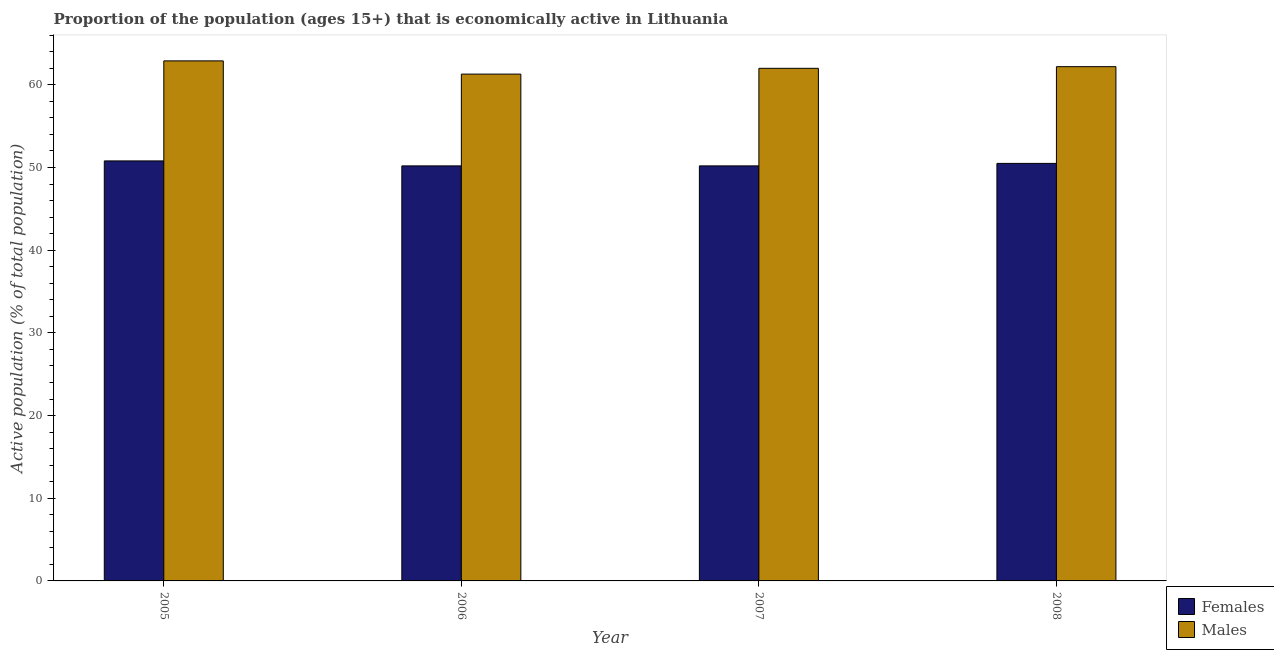How many groups of bars are there?
Your answer should be compact. 4. Are the number of bars on each tick of the X-axis equal?
Your answer should be very brief. Yes. How many bars are there on the 3rd tick from the right?
Keep it short and to the point. 2. What is the percentage of economically active female population in 2007?
Ensure brevity in your answer.  50.2. Across all years, what is the maximum percentage of economically active female population?
Your answer should be very brief. 50.8. Across all years, what is the minimum percentage of economically active male population?
Your response must be concise. 61.3. What is the total percentage of economically active male population in the graph?
Ensure brevity in your answer.  248.4. What is the difference between the percentage of economically active female population in 2005 and the percentage of economically active male population in 2006?
Provide a short and direct response. 0.6. What is the average percentage of economically active male population per year?
Offer a very short reply. 62.1. In the year 2007, what is the difference between the percentage of economically active female population and percentage of economically active male population?
Your answer should be very brief. 0. What is the ratio of the percentage of economically active female population in 2007 to that in 2008?
Offer a very short reply. 0.99. Is the percentage of economically active male population in 2006 less than that in 2007?
Your answer should be very brief. Yes. Is the difference between the percentage of economically active male population in 2007 and 2008 greater than the difference between the percentage of economically active female population in 2007 and 2008?
Keep it short and to the point. No. What is the difference between the highest and the second highest percentage of economically active female population?
Your response must be concise. 0.3. What is the difference between the highest and the lowest percentage of economically active female population?
Ensure brevity in your answer.  0.6. In how many years, is the percentage of economically active male population greater than the average percentage of economically active male population taken over all years?
Your answer should be compact. 2. Is the sum of the percentage of economically active female population in 2005 and 2007 greater than the maximum percentage of economically active male population across all years?
Provide a short and direct response. Yes. What does the 2nd bar from the left in 2006 represents?
Ensure brevity in your answer.  Males. What does the 1st bar from the right in 2005 represents?
Your response must be concise. Males. How many bars are there?
Make the answer very short. 8. Are all the bars in the graph horizontal?
Make the answer very short. No. Does the graph contain grids?
Keep it short and to the point. No. Where does the legend appear in the graph?
Ensure brevity in your answer.  Bottom right. How are the legend labels stacked?
Offer a very short reply. Vertical. What is the title of the graph?
Offer a very short reply. Proportion of the population (ages 15+) that is economically active in Lithuania. What is the label or title of the X-axis?
Provide a succinct answer. Year. What is the label or title of the Y-axis?
Your answer should be compact. Active population (% of total population). What is the Active population (% of total population) of Females in 2005?
Provide a succinct answer. 50.8. What is the Active population (% of total population) of Males in 2005?
Offer a very short reply. 62.9. What is the Active population (% of total population) of Females in 2006?
Offer a very short reply. 50.2. What is the Active population (% of total population) of Males in 2006?
Your response must be concise. 61.3. What is the Active population (% of total population) in Females in 2007?
Your response must be concise. 50.2. What is the Active population (% of total population) of Females in 2008?
Provide a succinct answer. 50.5. What is the Active population (% of total population) of Males in 2008?
Provide a short and direct response. 62.2. Across all years, what is the maximum Active population (% of total population) of Females?
Give a very brief answer. 50.8. Across all years, what is the maximum Active population (% of total population) in Males?
Provide a short and direct response. 62.9. Across all years, what is the minimum Active population (% of total population) of Females?
Offer a very short reply. 50.2. Across all years, what is the minimum Active population (% of total population) of Males?
Provide a succinct answer. 61.3. What is the total Active population (% of total population) of Females in the graph?
Provide a short and direct response. 201.7. What is the total Active population (% of total population) in Males in the graph?
Your response must be concise. 248.4. What is the difference between the Active population (% of total population) of Males in 2005 and that in 2007?
Your answer should be very brief. 0.9. What is the difference between the Active population (% of total population) in Females in 2006 and that in 2007?
Your answer should be very brief. 0. What is the difference between the Active population (% of total population) in Males in 2006 and that in 2007?
Offer a terse response. -0.7. What is the difference between the Active population (% of total population) in Females in 2005 and the Active population (% of total population) in Males in 2006?
Provide a succinct answer. -10.5. What is the difference between the Active population (% of total population) in Females in 2006 and the Active population (% of total population) in Males in 2007?
Your response must be concise. -11.8. What is the average Active population (% of total population) in Females per year?
Provide a succinct answer. 50.42. What is the average Active population (% of total population) in Males per year?
Your response must be concise. 62.1. In the year 2008, what is the difference between the Active population (% of total population) of Females and Active population (% of total population) of Males?
Provide a short and direct response. -11.7. What is the ratio of the Active population (% of total population) of Females in 2005 to that in 2006?
Provide a short and direct response. 1.01. What is the ratio of the Active population (% of total population) of Males in 2005 to that in 2006?
Your answer should be compact. 1.03. What is the ratio of the Active population (% of total population) in Males in 2005 to that in 2007?
Your answer should be very brief. 1.01. What is the ratio of the Active population (% of total population) of Females in 2005 to that in 2008?
Your answer should be compact. 1.01. What is the ratio of the Active population (% of total population) of Males in 2005 to that in 2008?
Your answer should be compact. 1.01. What is the ratio of the Active population (% of total population) in Males in 2006 to that in 2007?
Ensure brevity in your answer.  0.99. What is the ratio of the Active population (% of total population) in Females in 2006 to that in 2008?
Offer a terse response. 0.99. What is the ratio of the Active population (% of total population) of Males in 2006 to that in 2008?
Give a very brief answer. 0.99. What is the ratio of the Active population (% of total population) of Females in 2007 to that in 2008?
Provide a short and direct response. 0.99. What is the difference between the highest and the second highest Active population (% of total population) in Males?
Your answer should be compact. 0.7. What is the difference between the highest and the lowest Active population (% of total population) in Females?
Provide a short and direct response. 0.6. What is the difference between the highest and the lowest Active population (% of total population) of Males?
Keep it short and to the point. 1.6. 